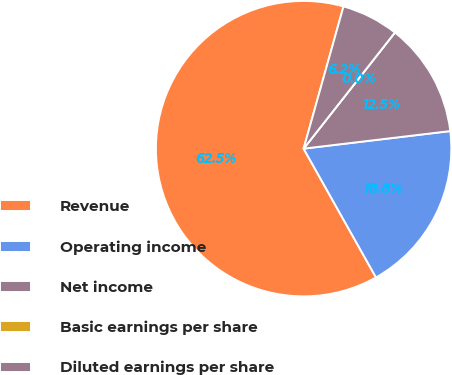<chart> <loc_0><loc_0><loc_500><loc_500><pie_chart><fcel>Revenue<fcel>Operating income<fcel>Net income<fcel>Basic earnings per share<fcel>Diluted earnings per share<nl><fcel>62.5%<fcel>18.75%<fcel>12.5%<fcel>0.0%<fcel>6.25%<nl></chart> 